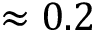Convert formula to latex. <formula><loc_0><loc_0><loc_500><loc_500>\approx 0 . 2</formula> 